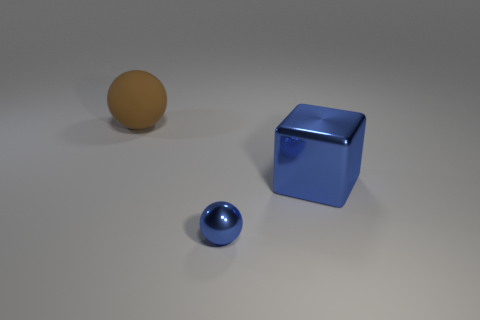There is another shiny object that is the same color as the tiny object; what is its shape?
Offer a terse response. Cube. Is the color of the tiny thing the same as the cube?
Offer a terse response. Yes. Is there any other thing that is the same size as the blue ball?
Give a very brief answer. No. There is a large object to the left of the large shiny thing; what number of big blue objects are in front of it?
Give a very brief answer. 1. Does the metal object right of the tiny sphere have the same color as the ball that is in front of the large rubber object?
Ensure brevity in your answer.  Yes. There is another object that is the same size as the brown rubber thing; what material is it?
Make the answer very short. Metal. What shape is the blue metal object that is to the right of the sphere that is right of the object that is left of the small blue shiny thing?
Your answer should be compact. Cube. The blue metallic thing that is the same size as the brown ball is what shape?
Make the answer very short. Cube. How many brown things are on the left side of the ball left of the blue object in front of the big blue cube?
Make the answer very short. 0. Are there more large blue shiny things that are in front of the large brown object than tiny metallic spheres that are on the left side of the small thing?
Your response must be concise. Yes. 